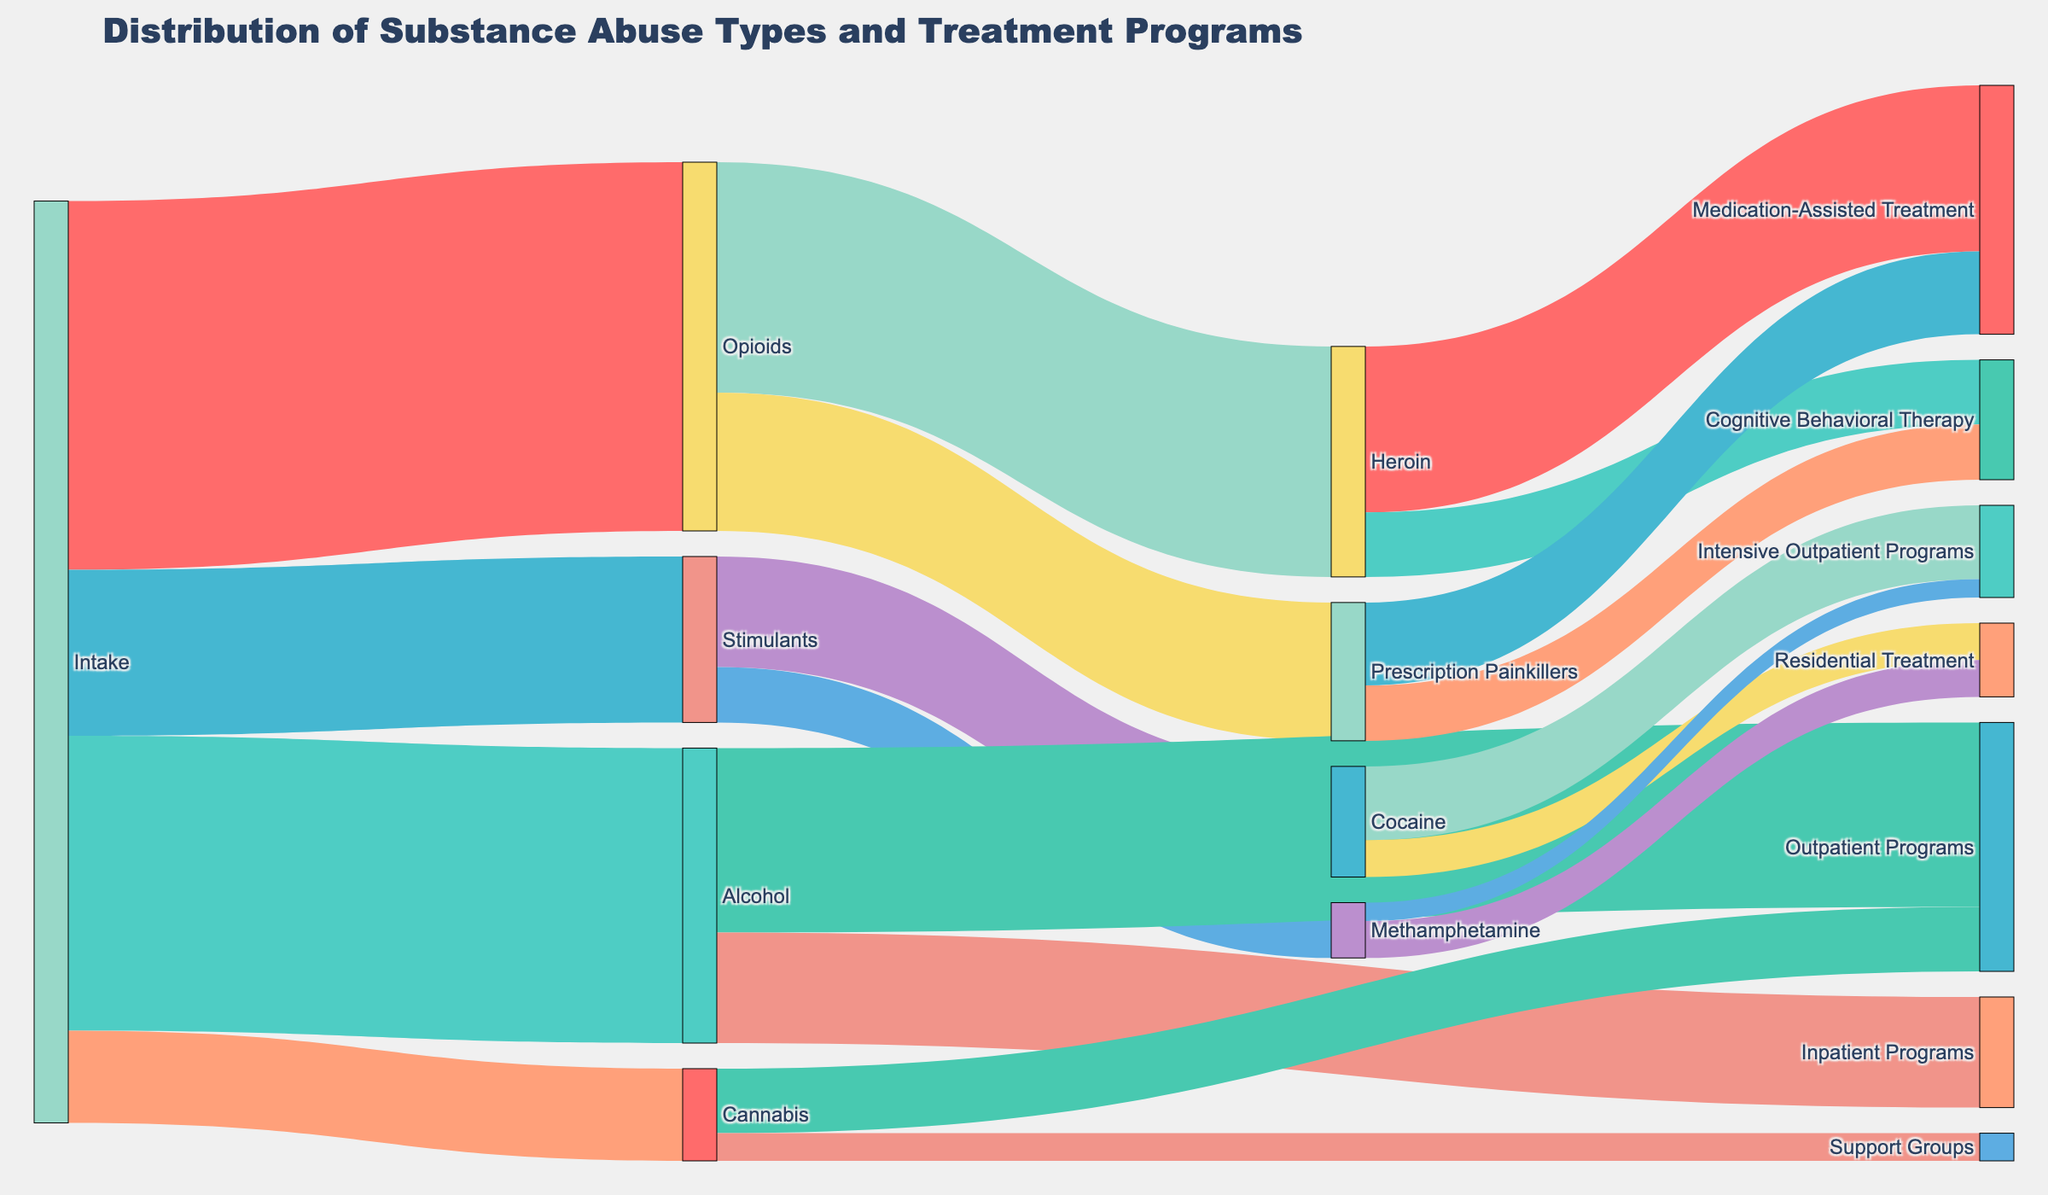what is the title of the figure? The title is usually the first thing noticeable in a figure. It summarizes what the chart is about, located at the top of the figure.
Answer: Distribution of Substance Abuse Types and Treatment Programs Which substance abuse type has the highest number of participants at intake? To find this, look at the values connected to the "Intake" source. Compare the values and identify the highest one.
Answer: Opioids How many participants are involved in Outpatient Programs from Alcohol and Cannabis combined? First, find the values for Outpatient Programs from Alcohol and Cannabis separately. Then, add these values together. The values are 200 (Alcohol) and 70 (Cannabis). So, 200 + 70 = 270.
Answer: 270 Which treatment program is primarily used for those with heroin addiction? Look at the links going from Heroin to the treatment programs. Compare the values for each connection to see which program has the highest value.
Answer: Medication-Assisted Treatment What is the difference in the number of participants between those using Outpatient Programs and those using Residential Treatment for stimulants? Identify the values for Outpatient Programs and Residential Treatment from the respective sources. For Stimulants, this is 0 for Outpatient Programs and 80 (40+40) for Residential Treatment. The difference is 80 - 0 = 80.
Answer: 80 Which substance abuse type has the least number of participants involved at intake? To determine this, examine the values linked to the "Intake" source, and identify the smallest value.
Answer: Cannabis What are the top two largest subcategories for opioid users? Look at the values connected from Opioids. Compare to identify the top two highest values among Heroin and Prescription Painkillers.
Answer: Heroin and Prescription Painkillers How many participants undergo Cognitive Behavioral Therapy from heroin and painkillers combined? Find the values connecting Heroin and Prescription Painkillers to Cognitive Behavioral Therapy, and sum them up. The values are 70 (Heroin) and 60 (Painkillers). So, 70 + 60 = 130.
Answer: 130 Which treatment programs show involvement for Methamphetamine users? Check the links originating from Methamphetamine and identify the target nodes connected to it.
Answer: Residential Treatment, Intensive Outpatient Programs What proportion of stimulant users use intensive outpatient programs compared to those in residential treatment? First, find the values for both programs for Stimulant users. The value for Intensive Outpatient Programs is 20 (Methamphetamine) + 80 (Cocaine) = 100, and for Residential Treatment, it is 40 (Methamphetamine) + 40 (Cocaine) = 80. The proportion is 100/80 = 1.25.
Answer: 1.25 